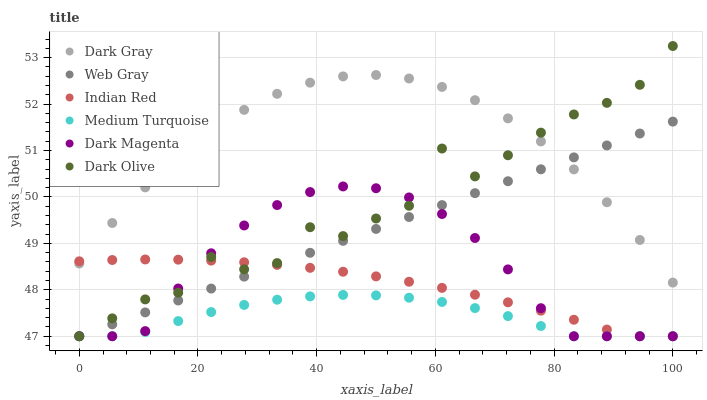Does Medium Turquoise have the minimum area under the curve?
Answer yes or no. Yes. Does Dark Gray have the maximum area under the curve?
Answer yes or no. Yes. Does Indian Red have the minimum area under the curve?
Answer yes or no. No. Does Indian Red have the maximum area under the curve?
Answer yes or no. No. Is Web Gray the smoothest?
Answer yes or no. Yes. Is Dark Olive the roughest?
Answer yes or no. Yes. Is Indian Red the smoothest?
Answer yes or no. No. Is Indian Red the roughest?
Answer yes or no. No. Does Web Gray have the lowest value?
Answer yes or no. Yes. Does Dark Gray have the lowest value?
Answer yes or no. No. Does Dark Olive have the highest value?
Answer yes or no. Yes. Does Indian Red have the highest value?
Answer yes or no. No. Is Medium Turquoise less than Dark Gray?
Answer yes or no. Yes. Is Dark Gray greater than Dark Magenta?
Answer yes or no. Yes. Does Web Gray intersect Dark Magenta?
Answer yes or no. Yes. Is Web Gray less than Dark Magenta?
Answer yes or no. No. Is Web Gray greater than Dark Magenta?
Answer yes or no. No. Does Medium Turquoise intersect Dark Gray?
Answer yes or no. No. 